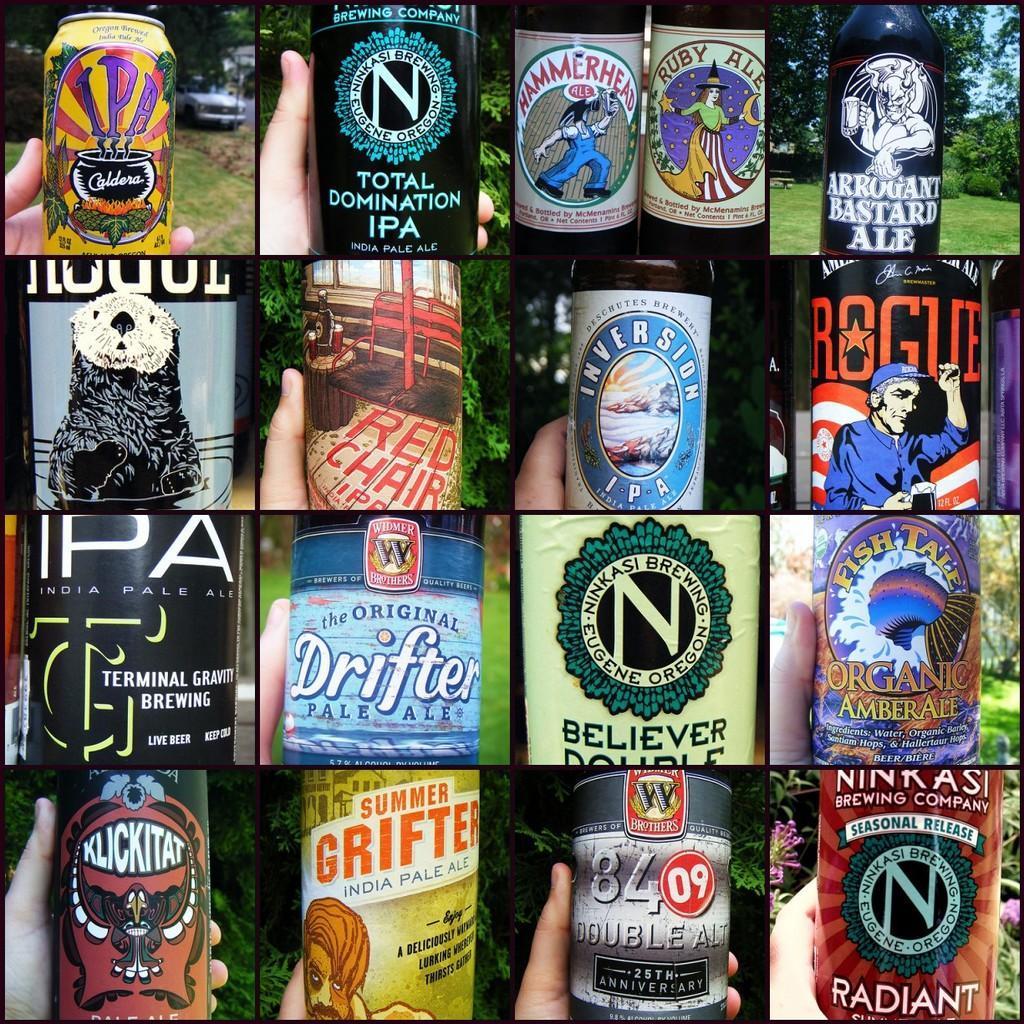Describe this image in one or two sentences. This picture is collage of different pictures. In every picture, there is a hand holding a bottle with different bottles and in the background there are trees. 